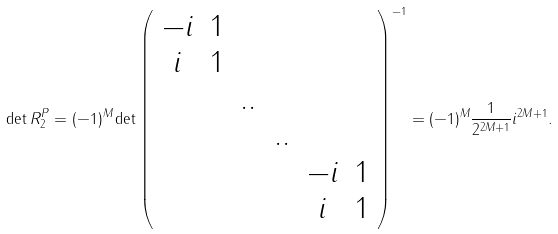<formula> <loc_0><loc_0><loc_500><loc_500>\det R ^ { P } _ { 2 } = ( - 1 ) ^ { M } \det \left ( \begin{array} { c c c c c c c c c c c } - i & 1 & & & & \\ i & 1 & & & & \\ & & . . & & & \\ & & & . . & \\ & & & & - i & 1 \\ & & & & i & 1 \end{array} \right ) ^ { - 1 } = ( - 1 ) ^ { M } \frac { 1 } { 2 ^ { 2 M + 1 } } i ^ { 2 M + 1 } .</formula> 